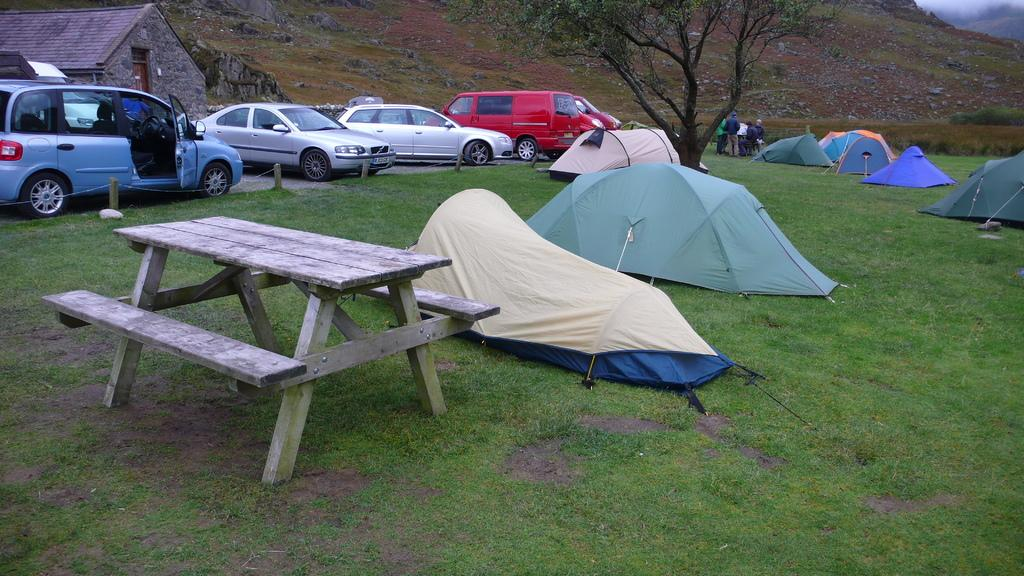What type of seating is visible in the image? There is a bench in the image. What type of temporary shelters can be seen in the image? There are tents in the image. What can be seen in the background of the image? There are vehicles, a house, people, a tree, and a mountain in the background of the image. Can you give an example of a stranger attempting to climb the mountain in the image? There is no stranger attempting to climb the mountain in the image; it only shows a bench, tents, and various background elements. 